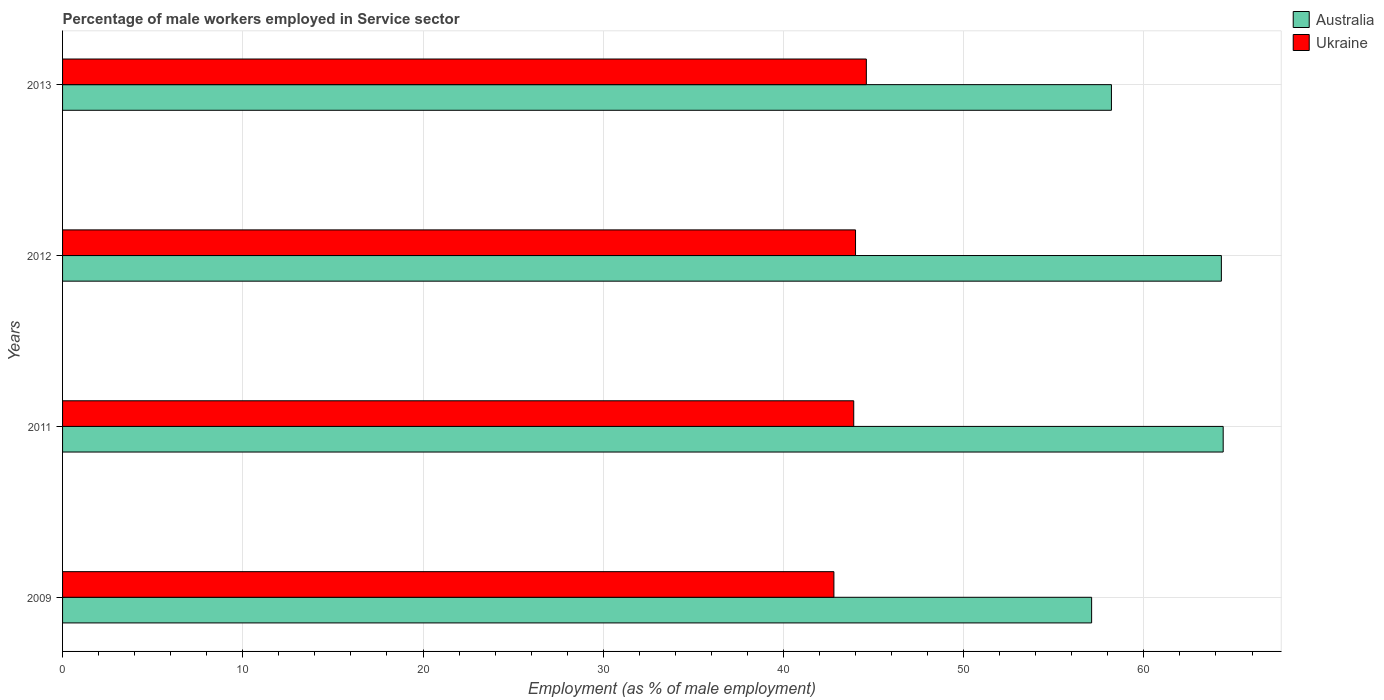Are the number of bars on each tick of the Y-axis equal?
Provide a succinct answer. Yes. How many bars are there on the 1st tick from the top?
Give a very brief answer. 2. What is the percentage of male workers employed in Service sector in Ukraine in 2009?
Your answer should be compact. 42.8. Across all years, what is the maximum percentage of male workers employed in Service sector in Ukraine?
Offer a terse response. 44.6. Across all years, what is the minimum percentage of male workers employed in Service sector in Australia?
Make the answer very short. 57.1. In which year was the percentage of male workers employed in Service sector in Ukraine minimum?
Ensure brevity in your answer.  2009. What is the total percentage of male workers employed in Service sector in Ukraine in the graph?
Provide a short and direct response. 175.3. What is the difference between the percentage of male workers employed in Service sector in Australia in 2009 and that in 2012?
Keep it short and to the point. -7.2. What is the difference between the percentage of male workers employed in Service sector in Australia in 2011 and the percentage of male workers employed in Service sector in Ukraine in 2012?
Offer a terse response. 20.4. What is the average percentage of male workers employed in Service sector in Australia per year?
Your answer should be very brief. 61. In the year 2009, what is the difference between the percentage of male workers employed in Service sector in Australia and percentage of male workers employed in Service sector in Ukraine?
Your answer should be compact. 14.3. What is the ratio of the percentage of male workers employed in Service sector in Australia in 2009 to that in 2011?
Your answer should be very brief. 0.89. What is the difference between the highest and the second highest percentage of male workers employed in Service sector in Australia?
Offer a very short reply. 0.1. What is the difference between the highest and the lowest percentage of male workers employed in Service sector in Ukraine?
Offer a terse response. 1.8. In how many years, is the percentage of male workers employed in Service sector in Ukraine greater than the average percentage of male workers employed in Service sector in Ukraine taken over all years?
Offer a very short reply. 3. Is the sum of the percentage of male workers employed in Service sector in Ukraine in 2009 and 2012 greater than the maximum percentage of male workers employed in Service sector in Australia across all years?
Provide a succinct answer. Yes. What does the 1st bar from the top in 2012 represents?
Provide a short and direct response. Ukraine. What does the 2nd bar from the bottom in 2013 represents?
Your answer should be compact. Ukraine. How many bars are there?
Your response must be concise. 8. What is the difference between two consecutive major ticks on the X-axis?
Your response must be concise. 10. Are the values on the major ticks of X-axis written in scientific E-notation?
Your answer should be compact. No. Does the graph contain grids?
Offer a terse response. Yes. How many legend labels are there?
Offer a terse response. 2. What is the title of the graph?
Your answer should be very brief. Percentage of male workers employed in Service sector. What is the label or title of the X-axis?
Keep it short and to the point. Employment (as % of male employment). What is the Employment (as % of male employment) in Australia in 2009?
Your response must be concise. 57.1. What is the Employment (as % of male employment) in Ukraine in 2009?
Keep it short and to the point. 42.8. What is the Employment (as % of male employment) in Australia in 2011?
Offer a very short reply. 64.4. What is the Employment (as % of male employment) of Ukraine in 2011?
Give a very brief answer. 43.9. What is the Employment (as % of male employment) of Australia in 2012?
Your response must be concise. 64.3. What is the Employment (as % of male employment) of Ukraine in 2012?
Offer a terse response. 44. What is the Employment (as % of male employment) in Australia in 2013?
Keep it short and to the point. 58.2. What is the Employment (as % of male employment) of Ukraine in 2013?
Give a very brief answer. 44.6. Across all years, what is the maximum Employment (as % of male employment) of Australia?
Provide a succinct answer. 64.4. Across all years, what is the maximum Employment (as % of male employment) in Ukraine?
Provide a short and direct response. 44.6. Across all years, what is the minimum Employment (as % of male employment) of Australia?
Give a very brief answer. 57.1. Across all years, what is the minimum Employment (as % of male employment) of Ukraine?
Give a very brief answer. 42.8. What is the total Employment (as % of male employment) in Australia in the graph?
Give a very brief answer. 244. What is the total Employment (as % of male employment) of Ukraine in the graph?
Offer a terse response. 175.3. What is the difference between the Employment (as % of male employment) of Australia in 2009 and that in 2011?
Give a very brief answer. -7.3. What is the difference between the Employment (as % of male employment) of Australia in 2009 and that in 2012?
Make the answer very short. -7.2. What is the difference between the Employment (as % of male employment) in Australia in 2011 and that in 2012?
Give a very brief answer. 0.1. What is the difference between the Employment (as % of male employment) of Ukraine in 2011 and that in 2012?
Make the answer very short. -0.1. What is the difference between the Employment (as % of male employment) of Australia in 2011 and that in 2013?
Your answer should be very brief. 6.2. What is the difference between the Employment (as % of male employment) of Ukraine in 2012 and that in 2013?
Your answer should be compact. -0.6. What is the difference between the Employment (as % of male employment) in Australia in 2009 and the Employment (as % of male employment) in Ukraine in 2011?
Keep it short and to the point. 13.2. What is the difference between the Employment (as % of male employment) of Australia in 2009 and the Employment (as % of male employment) of Ukraine in 2012?
Make the answer very short. 13.1. What is the difference between the Employment (as % of male employment) of Australia in 2011 and the Employment (as % of male employment) of Ukraine in 2012?
Offer a terse response. 20.4. What is the difference between the Employment (as % of male employment) in Australia in 2011 and the Employment (as % of male employment) in Ukraine in 2013?
Offer a terse response. 19.8. What is the difference between the Employment (as % of male employment) of Australia in 2012 and the Employment (as % of male employment) of Ukraine in 2013?
Keep it short and to the point. 19.7. What is the average Employment (as % of male employment) of Ukraine per year?
Provide a short and direct response. 43.83. In the year 2009, what is the difference between the Employment (as % of male employment) in Australia and Employment (as % of male employment) in Ukraine?
Your response must be concise. 14.3. In the year 2012, what is the difference between the Employment (as % of male employment) in Australia and Employment (as % of male employment) in Ukraine?
Your answer should be very brief. 20.3. In the year 2013, what is the difference between the Employment (as % of male employment) in Australia and Employment (as % of male employment) in Ukraine?
Keep it short and to the point. 13.6. What is the ratio of the Employment (as % of male employment) in Australia in 2009 to that in 2011?
Offer a very short reply. 0.89. What is the ratio of the Employment (as % of male employment) in Ukraine in 2009 to that in 2011?
Make the answer very short. 0.97. What is the ratio of the Employment (as % of male employment) in Australia in 2009 to that in 2012?
Provide a short and direct response. 0.89. What is the ratio of the Employment (as % of male employment) in Ukraine in 2009 to that in 2012?
Keep it short and to the point. 0.97. What is the ratio of the Employment (as % of male employment) in Australia in 2009 to that in 2013?
Make the answer very short. 0.98. What is the ratio of the Employment (as % of male employment) of Ukraine in 2009 to that in 2013?
Provide a succinct answer. 0.96. What is the ratio of the Employment (as % of male employment) of Australia in 2011 to that in 2013?
Offer a very short reply. 1.11. What is the ratio of the Employment (as % of male employment) in Ukraine in 2011 to that in 2013?
Your answer should be very brief. 0.98. What is the ratio of the Employment (as % of male employment) of Australia in 2012 to that in 2013?
Your answer should be compact. 1.1. What is the ratio of the Employment (as % of male employment) in Ukraine in 2012 to that in 2013?
Provide a short and direct response. 0.99. 